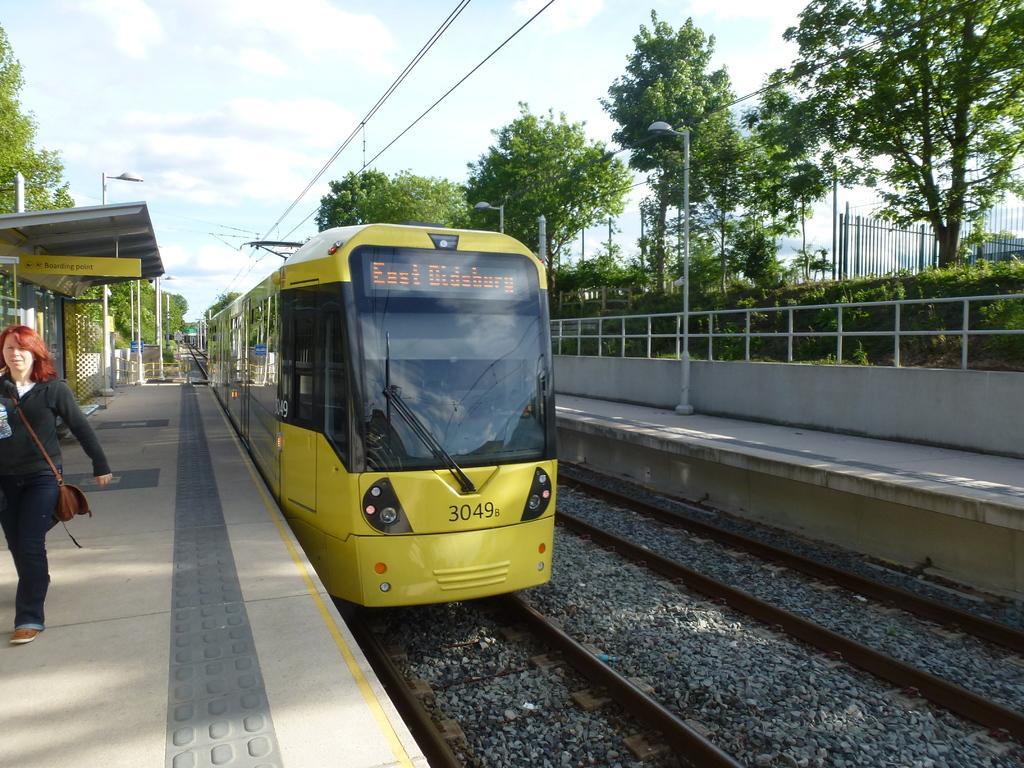In one or two sentences, can you explain what this image depicts? In this picture we can see two railway tracks and an one railway track we can see a train, beside these railway tracks we can see a woman and platforms and in the background we can see trees, electric poles, sky and some objects. 